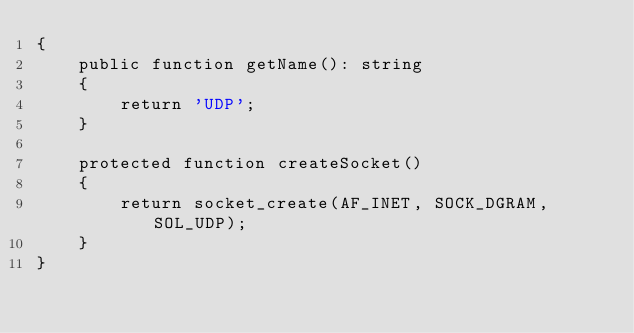Convert code to text. <code><loc_0><loc_0><loc_500><loc_500><_PHP_>{
    public function getName(): string
    {
        return 'UDP';
    }

    protected function createSocket()
    {
        return socket_create(AF_INET, SOCK_DGRAM, SOL_UDP);
    }
}</code> 